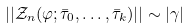<formula> <loc_0><loc_0><loc_500><loc_500>| | { \mathcal { Z } } _ { n } ( \varphi ; \bar { \tau } _ { 0 } , \dots , \bar { \tau } _ { k } ) | | \sim | \gamma |</formula> 